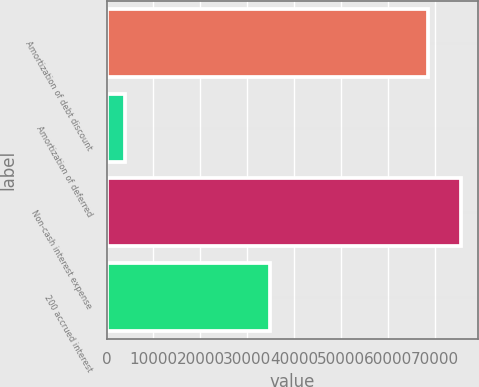<chart> <loc_0><loc_0><loc_500><loc_500><bar_chart><fcel>Amortization of debt discount<fcel>Amortization of deferred<fcel>Non-cash interest expense<fcel>200 accrued interest<nl><fcel>68532<fcel>3828<fcel>75385.2<fcel>34898<nl></chart> 